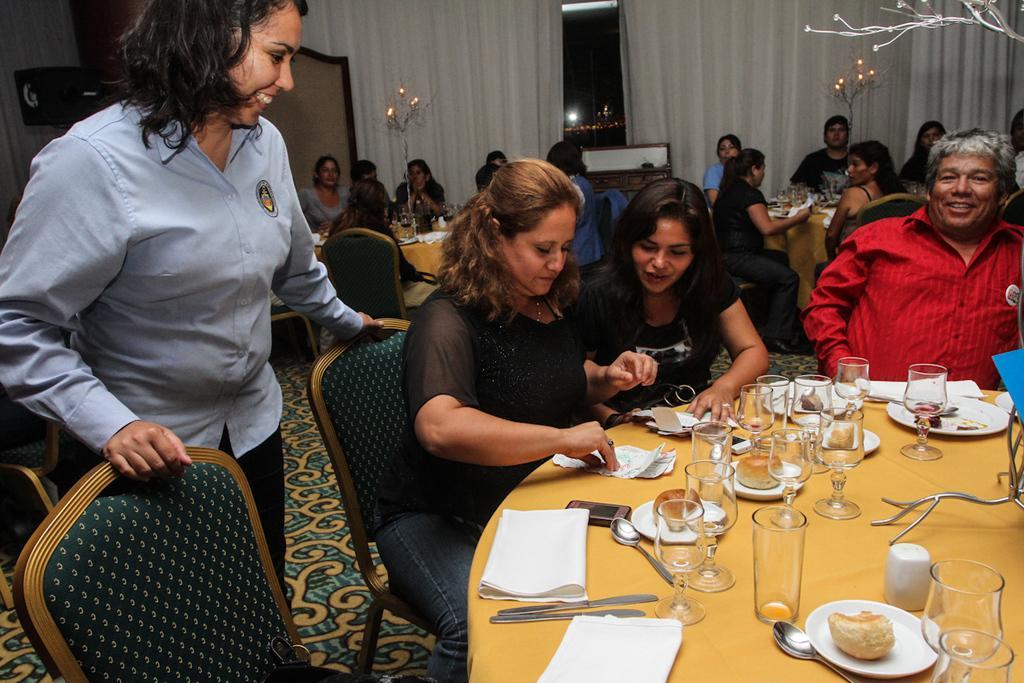In one or two sentences, can you explain what this image depicts? In this room group of people are sitting on chairs. In-front of them there are tables, on this table there is a cloth, mobile, spoon, knife, glasses, paper, plates and food. This woman is standing beside this chair and smiling. This is window with curtains. 